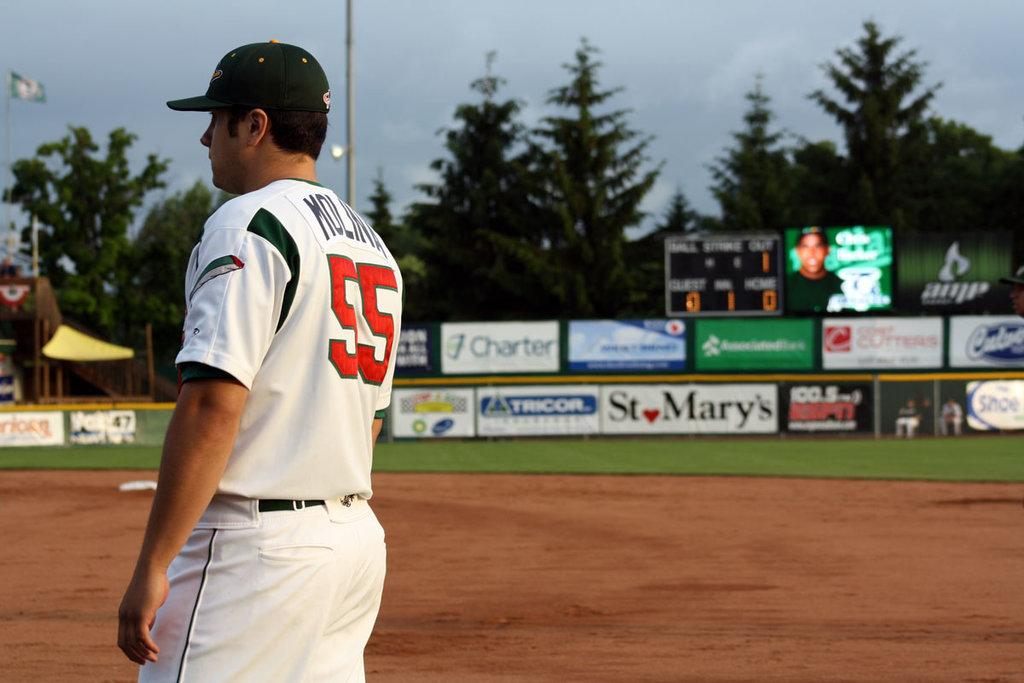<image>
Render a clear and concise summary of the photo. the number 55 is on the back of a shirt 